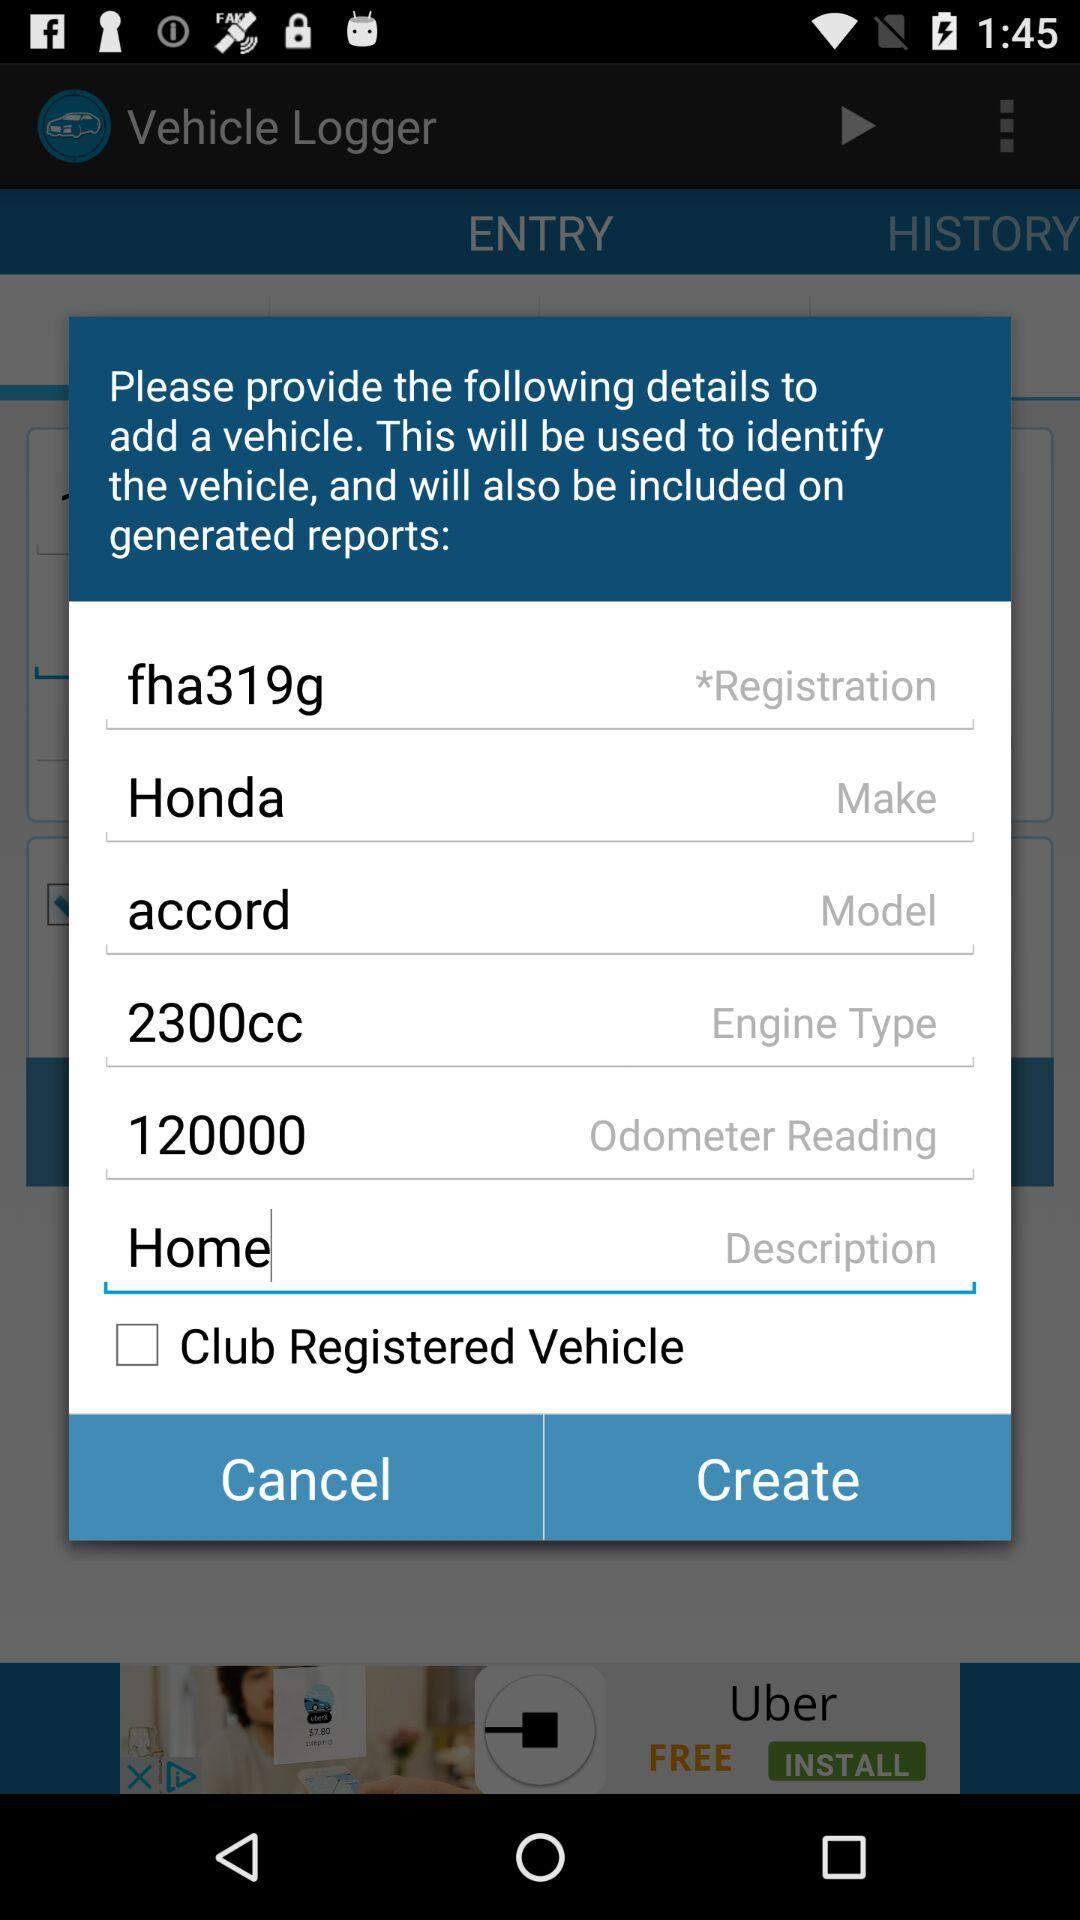How many items are in "HISTORY"?
When the provided information is insufficient, respond with <no answer>. <no answer> 